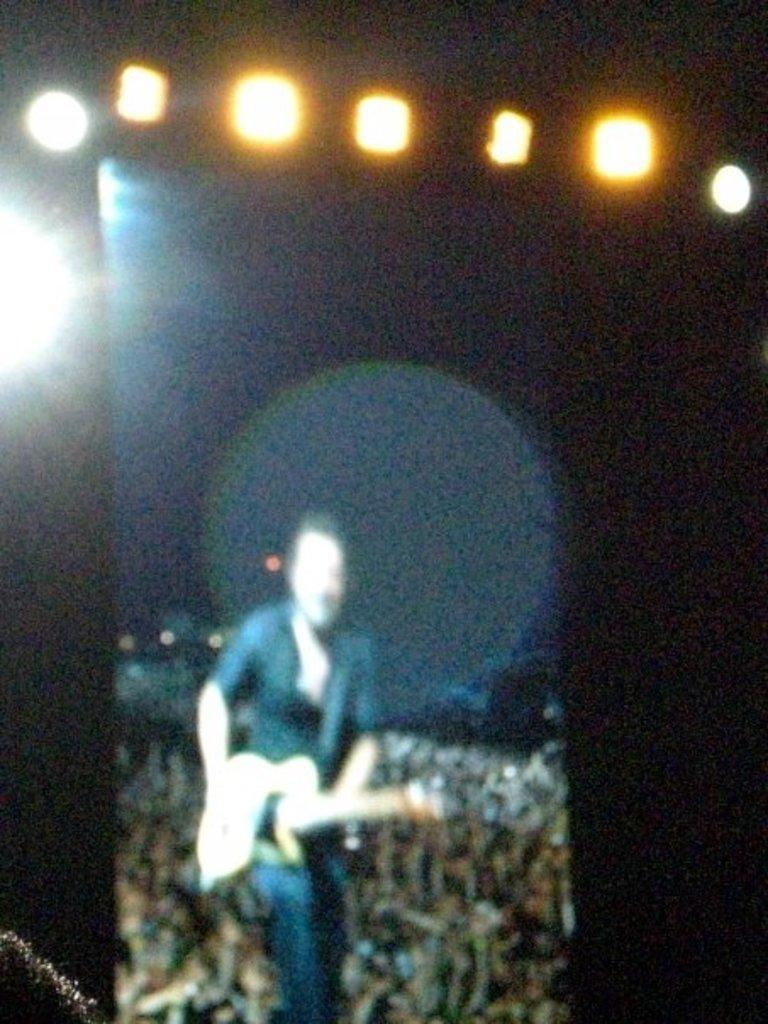Who is the main subject in the image? There is a man in the image. What is the man holding in the image? The man is holding a guitar. Can you describe the background of the image? There is a crowd of people behind the man. What can be seen at the top of the image? There are lights visible at the top of the image. What type of wood is the man using to control the crowd in the image? There is no wood or control mentioned in the image; the man is simply holding a guitar. 